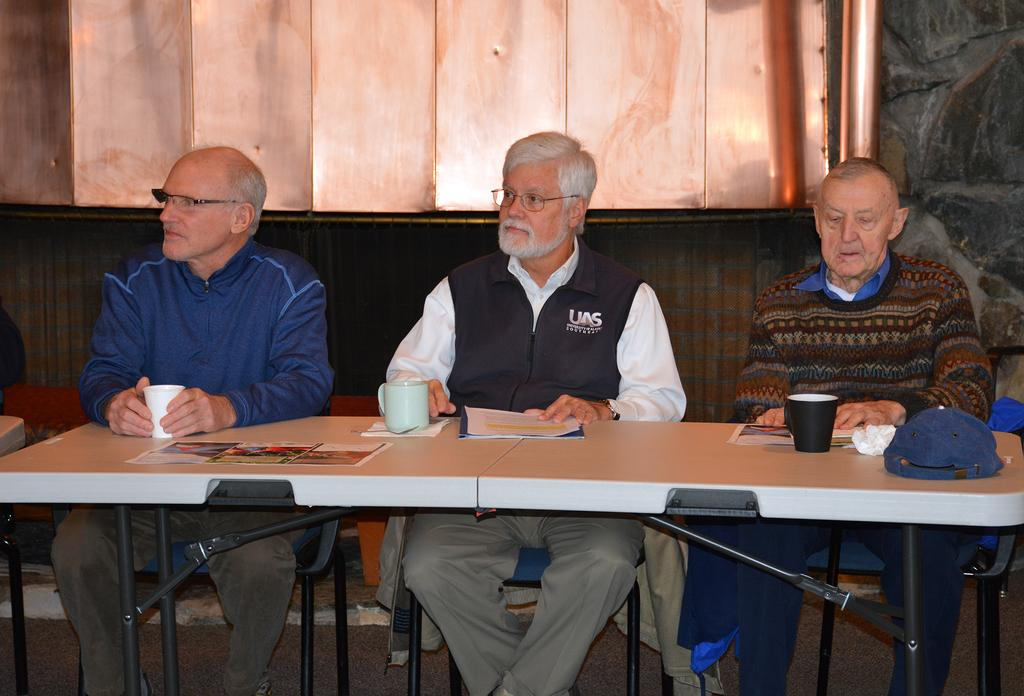How many men are in the image? There are three men in the image. What are the men doing in the image? The men are sitting on chairs and looking at someone. What is present on the table in the image? A glass, a cup, and papers are present on the table. What type of trucks can be seen in the image? There are no trucks present in the image. What system is being used by the men to communicate in the image? The image does not provide information about any communication system being used by the men. 